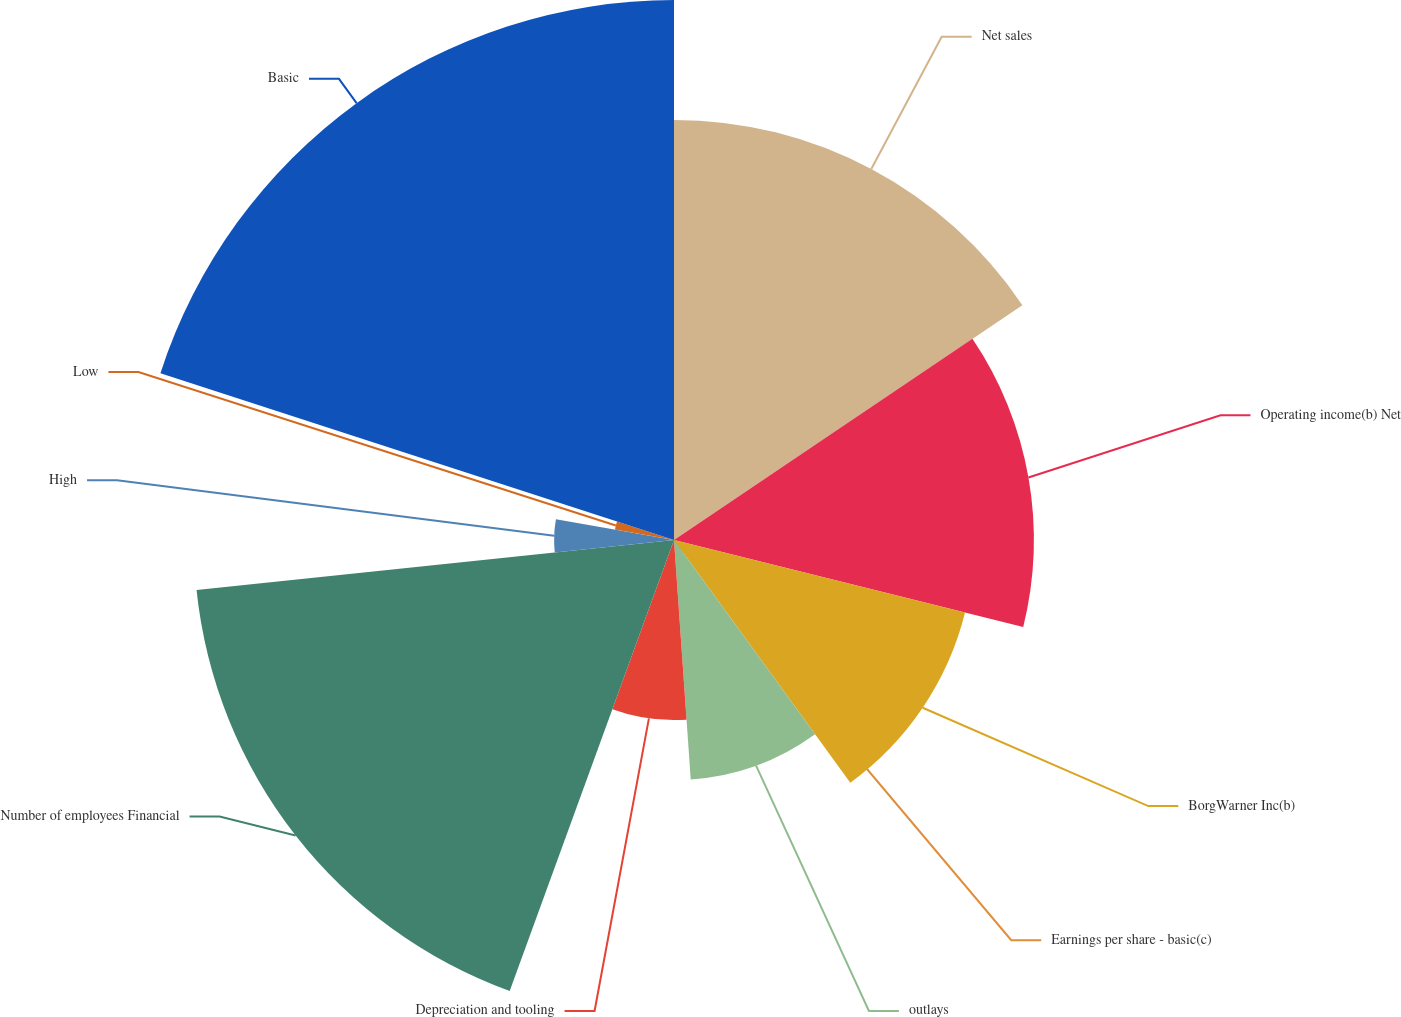<chart> <loc_0><loc_0><loc_500><loc_500><pie_chart><fcel>Net sales<fcel>Operating income(b) Net<fcel>BorgWarner Inc(b)<fcel>Earnings per share - basic(c)<fcel>outlays<fcel>Depreciation and tooling<fcel>Number of employees Financial<fcel>High<fcel>Low<fcel>Basic<nl><fcel>15.56%<fcel>13.33%<fcel>11.11%<fcel>0.0%<fcel>8.89%<fcel>6.67%<fcel>17.78%<fcel>4.44%<fcel>2.22%<fcel>20.0%<nl></chart> 